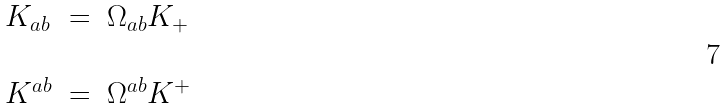Convert formula to latex. <formula><loc_0><loc_0><loc_500><loc_500>\begin{array} { l l l } K _ { a b } & = & \Omega _ { a b } K _ { + } \\ & & \\ K ^ { a b } & = & \Omega ^ { a b } K ^ { + } \end{array}</formula> 